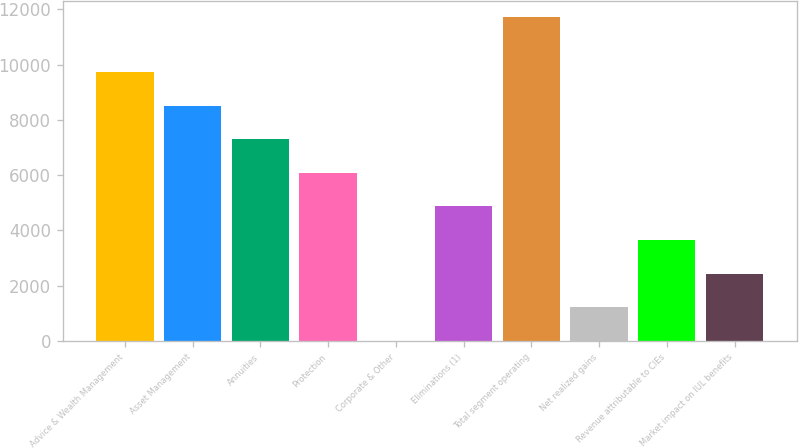<chart> <loc_0><loc_0><loc_500><loc_500><bar_chart><fcel>Advice & Wealth Management<fcel>Asset Management<fcel>Annuities<fcel>Protection<fcel>Corporate & Other<fcel>Eliminations (1)<fcel>Total segment operating<fcel>Net realized gains<fcel>Revenue attributable to CIEs<fcel>Market impact on IUL benefits<nl><fcel>9736.6<fcel>8519.9<fcel>7303.2<fcel>6086.5<fcel>3<fcel>4869.8<fcel>11734<fcel>1219.7<fcel>3653.1<fcel>2436.4<nl></chart> 